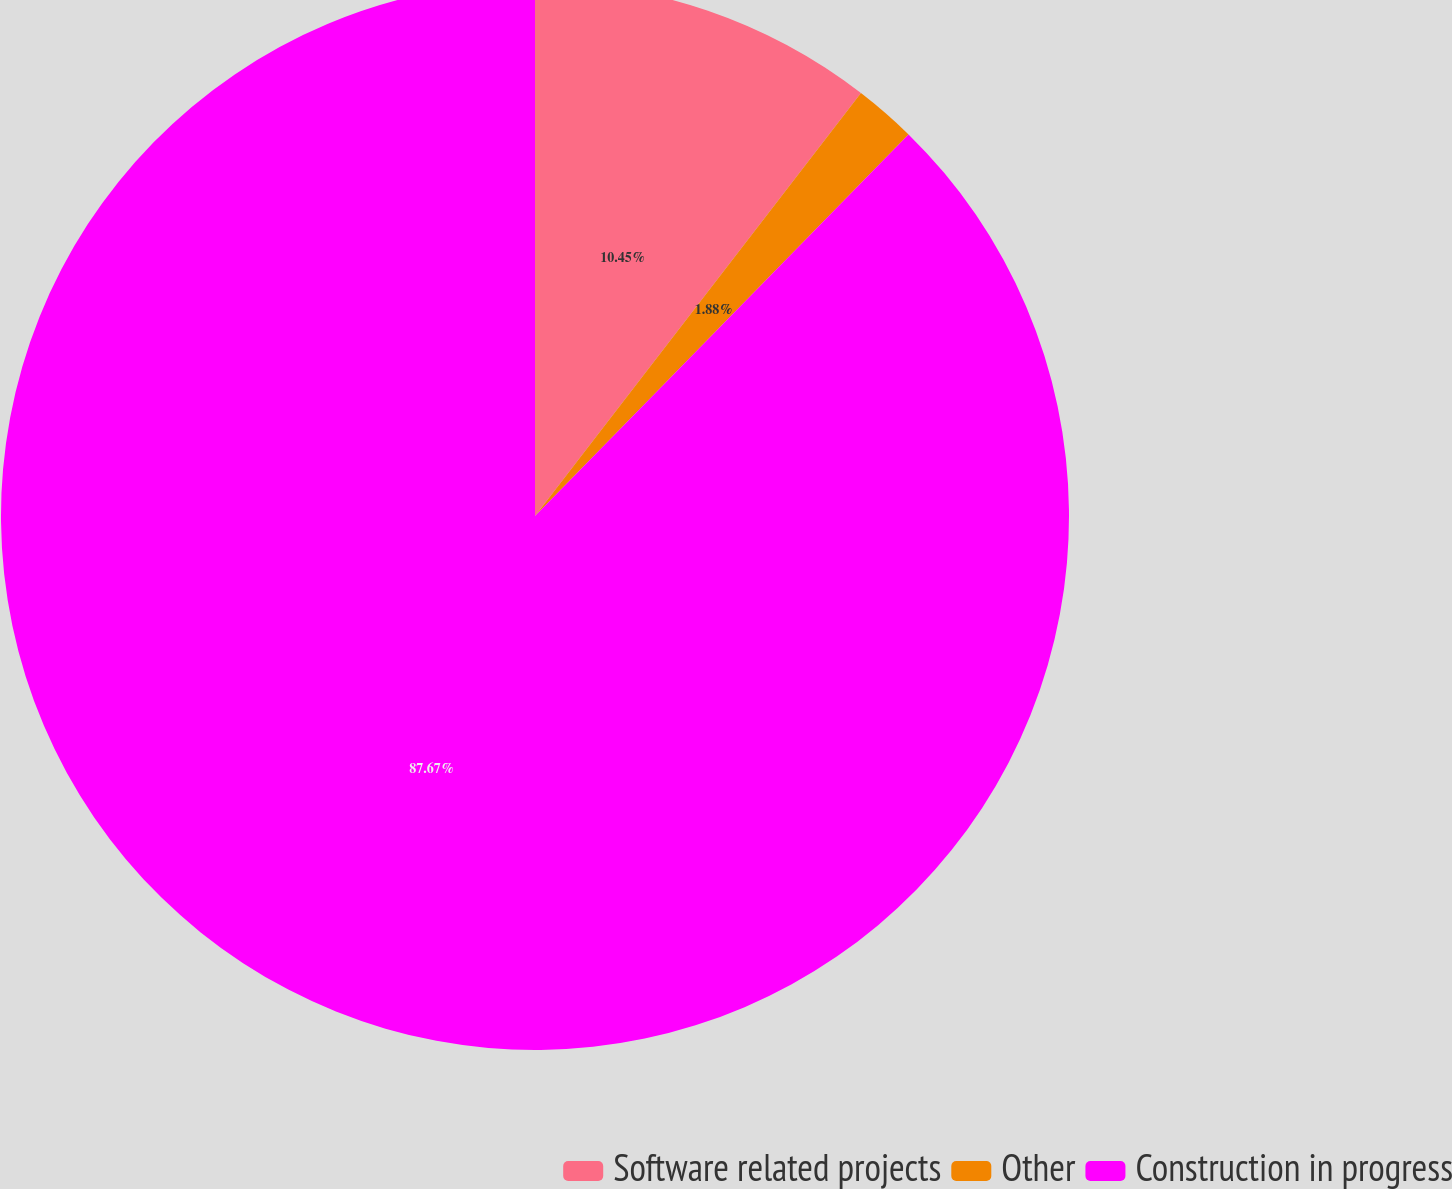Convert chart to OTSL. <chart><loc_0><loc_0><loc_500><loc_500><pie_chart><fcel>Software related projects<fcel>Other<fcel>Construction in progress<nl><fcel>10.45%<fcel>1.88%<fcel>87.67%<nl></chart> 